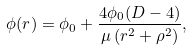<formula> <loc_0><loc_0><loc_500><loc_500>\phi ( r ) = \phi _ { 0 } + \frac { 4 \phi _ { 0 } ( D - 4 ) } { \mu \left ( r ^ { 2 } + \rho ^ { 2 } \right ) } ,</formula> 